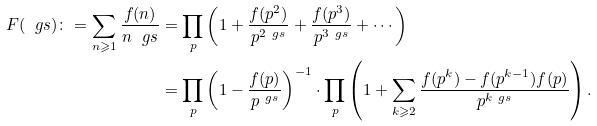Convert formula to latex. <formula><loc_0><loc_0><loc_500><loc_500>F ( \ g s ) \colon = \sum _ { n \geqslant 1 } \frac { f ( n ) } { n ^ { \ } g s } & = \prod _ { p } \left ( 1 + \frac { f ( p ^ { 2 } ) } { p ^ { 2 \ g s } } + \frac { f ( p ^ { 3 } ) } { p ^ { 3 \ g s } } + \cdots \right ) \\ & = \prod _ { p } \left ( 1 - \frac { f ( p ) } { p ^ { \ g s } } \right ) ^ { - 1 } \cdot \prod _ { p } \left ( 1 + \sum _ { k \geqslant 2 } \frac { f ( p ^ { k } ) - f ( p ^ { k - 1 } ) f ( p ) } { p ^ { k \ g s } } \right ) .</formula> 